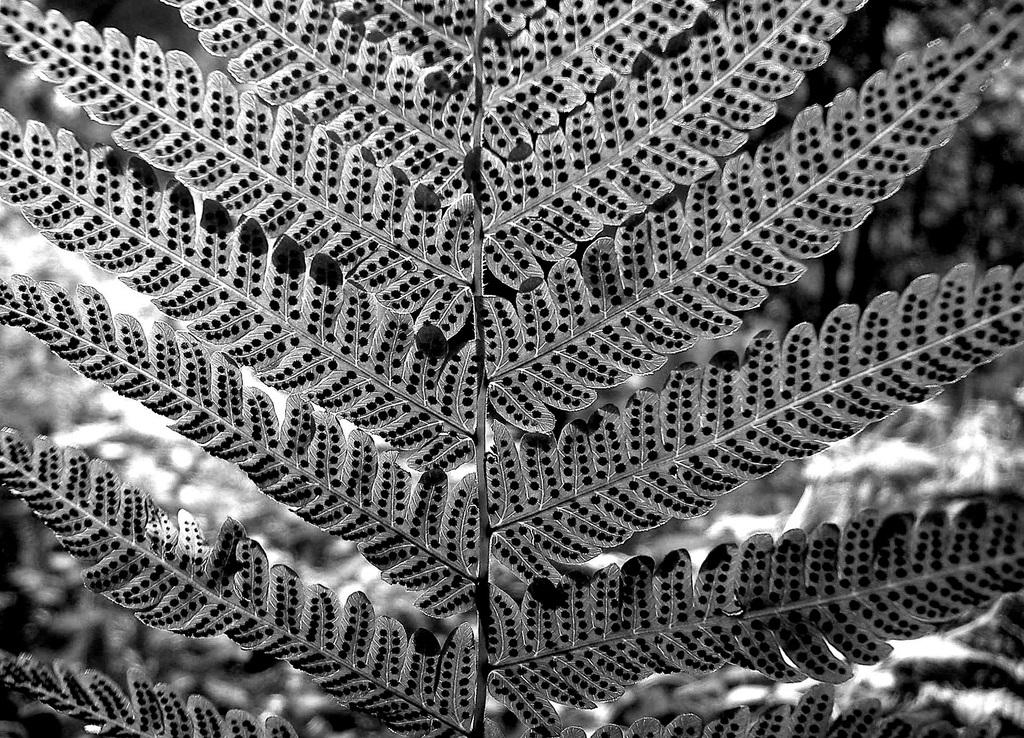What is the color scheme of the image? The image is black and white. What type of vegetation can be seen in the image? There are leaves in the image. What part of the plant is visible in the image? There is a stem in the image. What type of shirt is being sorted by the property manager in the image? There is no shirt, sorting, or property manager present in the image. 